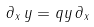Convert formula to latex. <formula><loc_0><loc_0><loc_500><loc_500>\partial _ { x } \, y = q y \, \partial _ { x }</formula> 